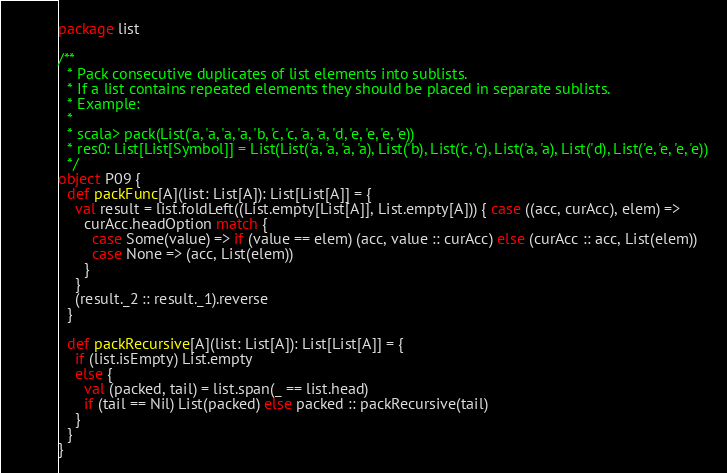<code> <loc_0><loc_0><loc_500><loc_500><_Scala_>package list

/**
  * Pack consecutive duplicates of list elements into sublists.
  * If a list contains repeated elements they should be placed in separate sublists.
  * Example:
  *
  * scala> pack(List('a, 'a, 'a, 'a, 'b, 'c, 'c, 'a, 'a, 'd, 'e, 'e, 'e, 'e))
  * res0: List[List[Symbol]] = List(List('a, 'a, 'a, 'a), List('b), List('c, 'c), List('a, 'a), List('d), List('e, 'e, 'e, 'e))
  */
object P09 {
  def packFunc[A](list: List[A]): List[List[A]] = {
    val result = list.foldLeft((List.empty[List[A]], List.empty[A])) { case ((acc, curAcc), elem) =>
      curAcc.headOption match {
        case Some(value) => if (value == elem) (acc, value :: curAcc) else (curAcc :: acc, List(elem))
        case None => (acc, List(elem))
      }
    }
    (result._2 :: result._1).reverse
  }

  def packRecursive[A](list: List[A]): List[List[A]] = {
    if (list.isEmpty) List.empty
    else {
      val (packed, tail) = list.span(_ == list.head)
      if (tail == Nil) List(packed) else packed :: packRecursive(tail)
    }
  }
}
</code> 